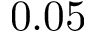Convert formula to latex. <formula><loc_0><loc_0><loc_500><loc_500>0 . 0 5</formula> 